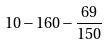<formula> <loc_0><loc_0><loc_500><loc_500>1 0 - 1 6 0 - \frac { 6 9 } { 1 5 0 }</formula> 